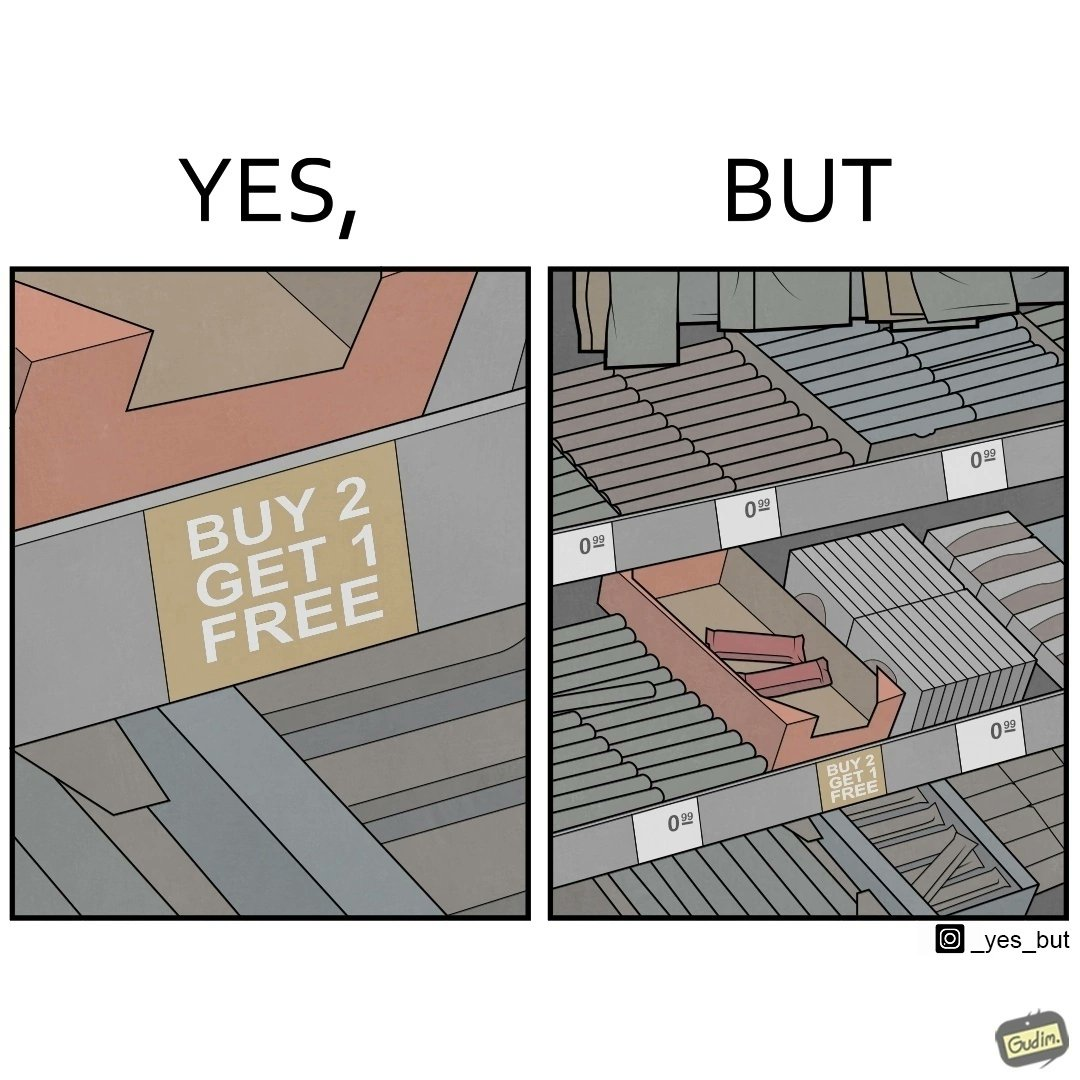Explain why this image is satirical. The image is funny because while there is an offer that lets the buyer have a free item if they buy two items of the product, there is only two units left which means that the buyer won't get the free unit. 